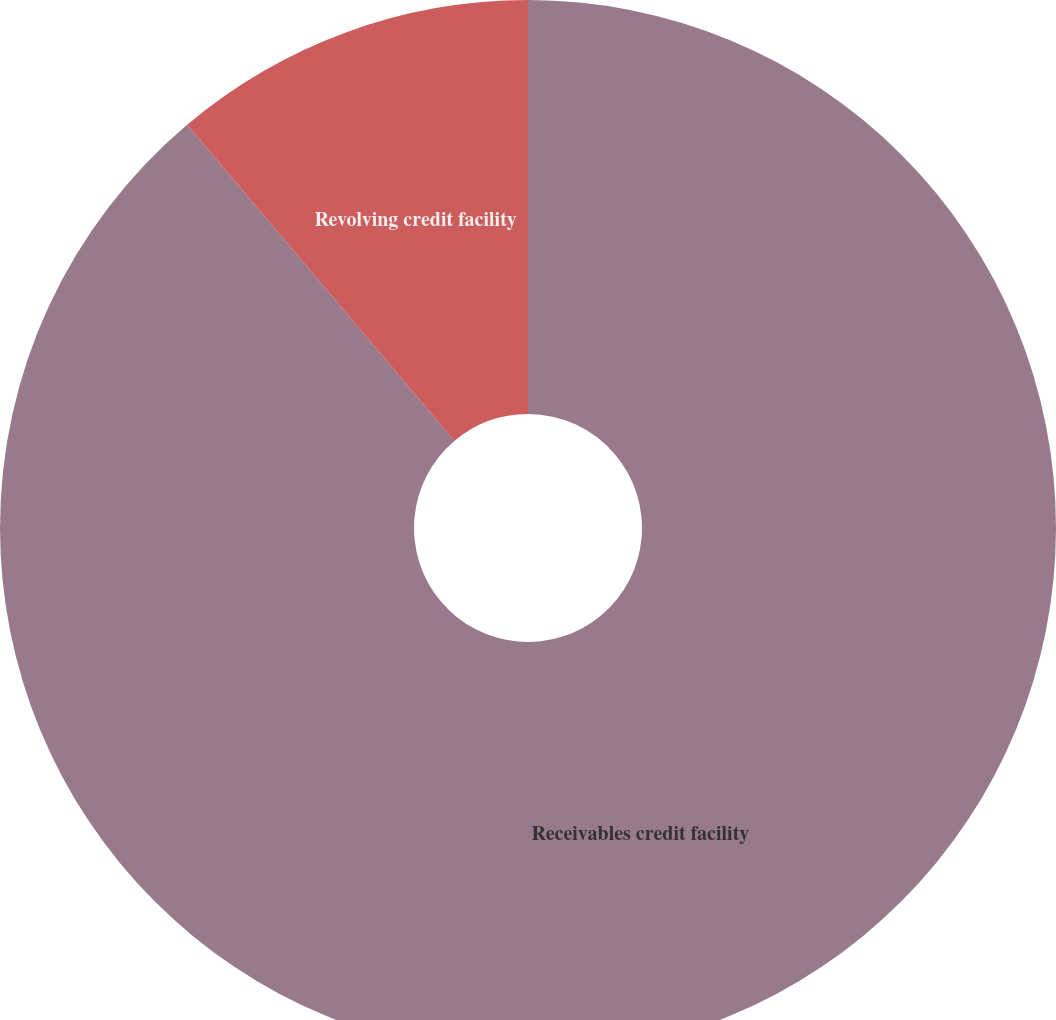Convert chart to OTSL. <chart><loc_0><loc_0><loc_500><loc_500><pie_chart><fcel>Receivables credit facility<fcel>Revolving credit facility<nl><fcel>88.83%<fcel>11.17%<nl></chart> 